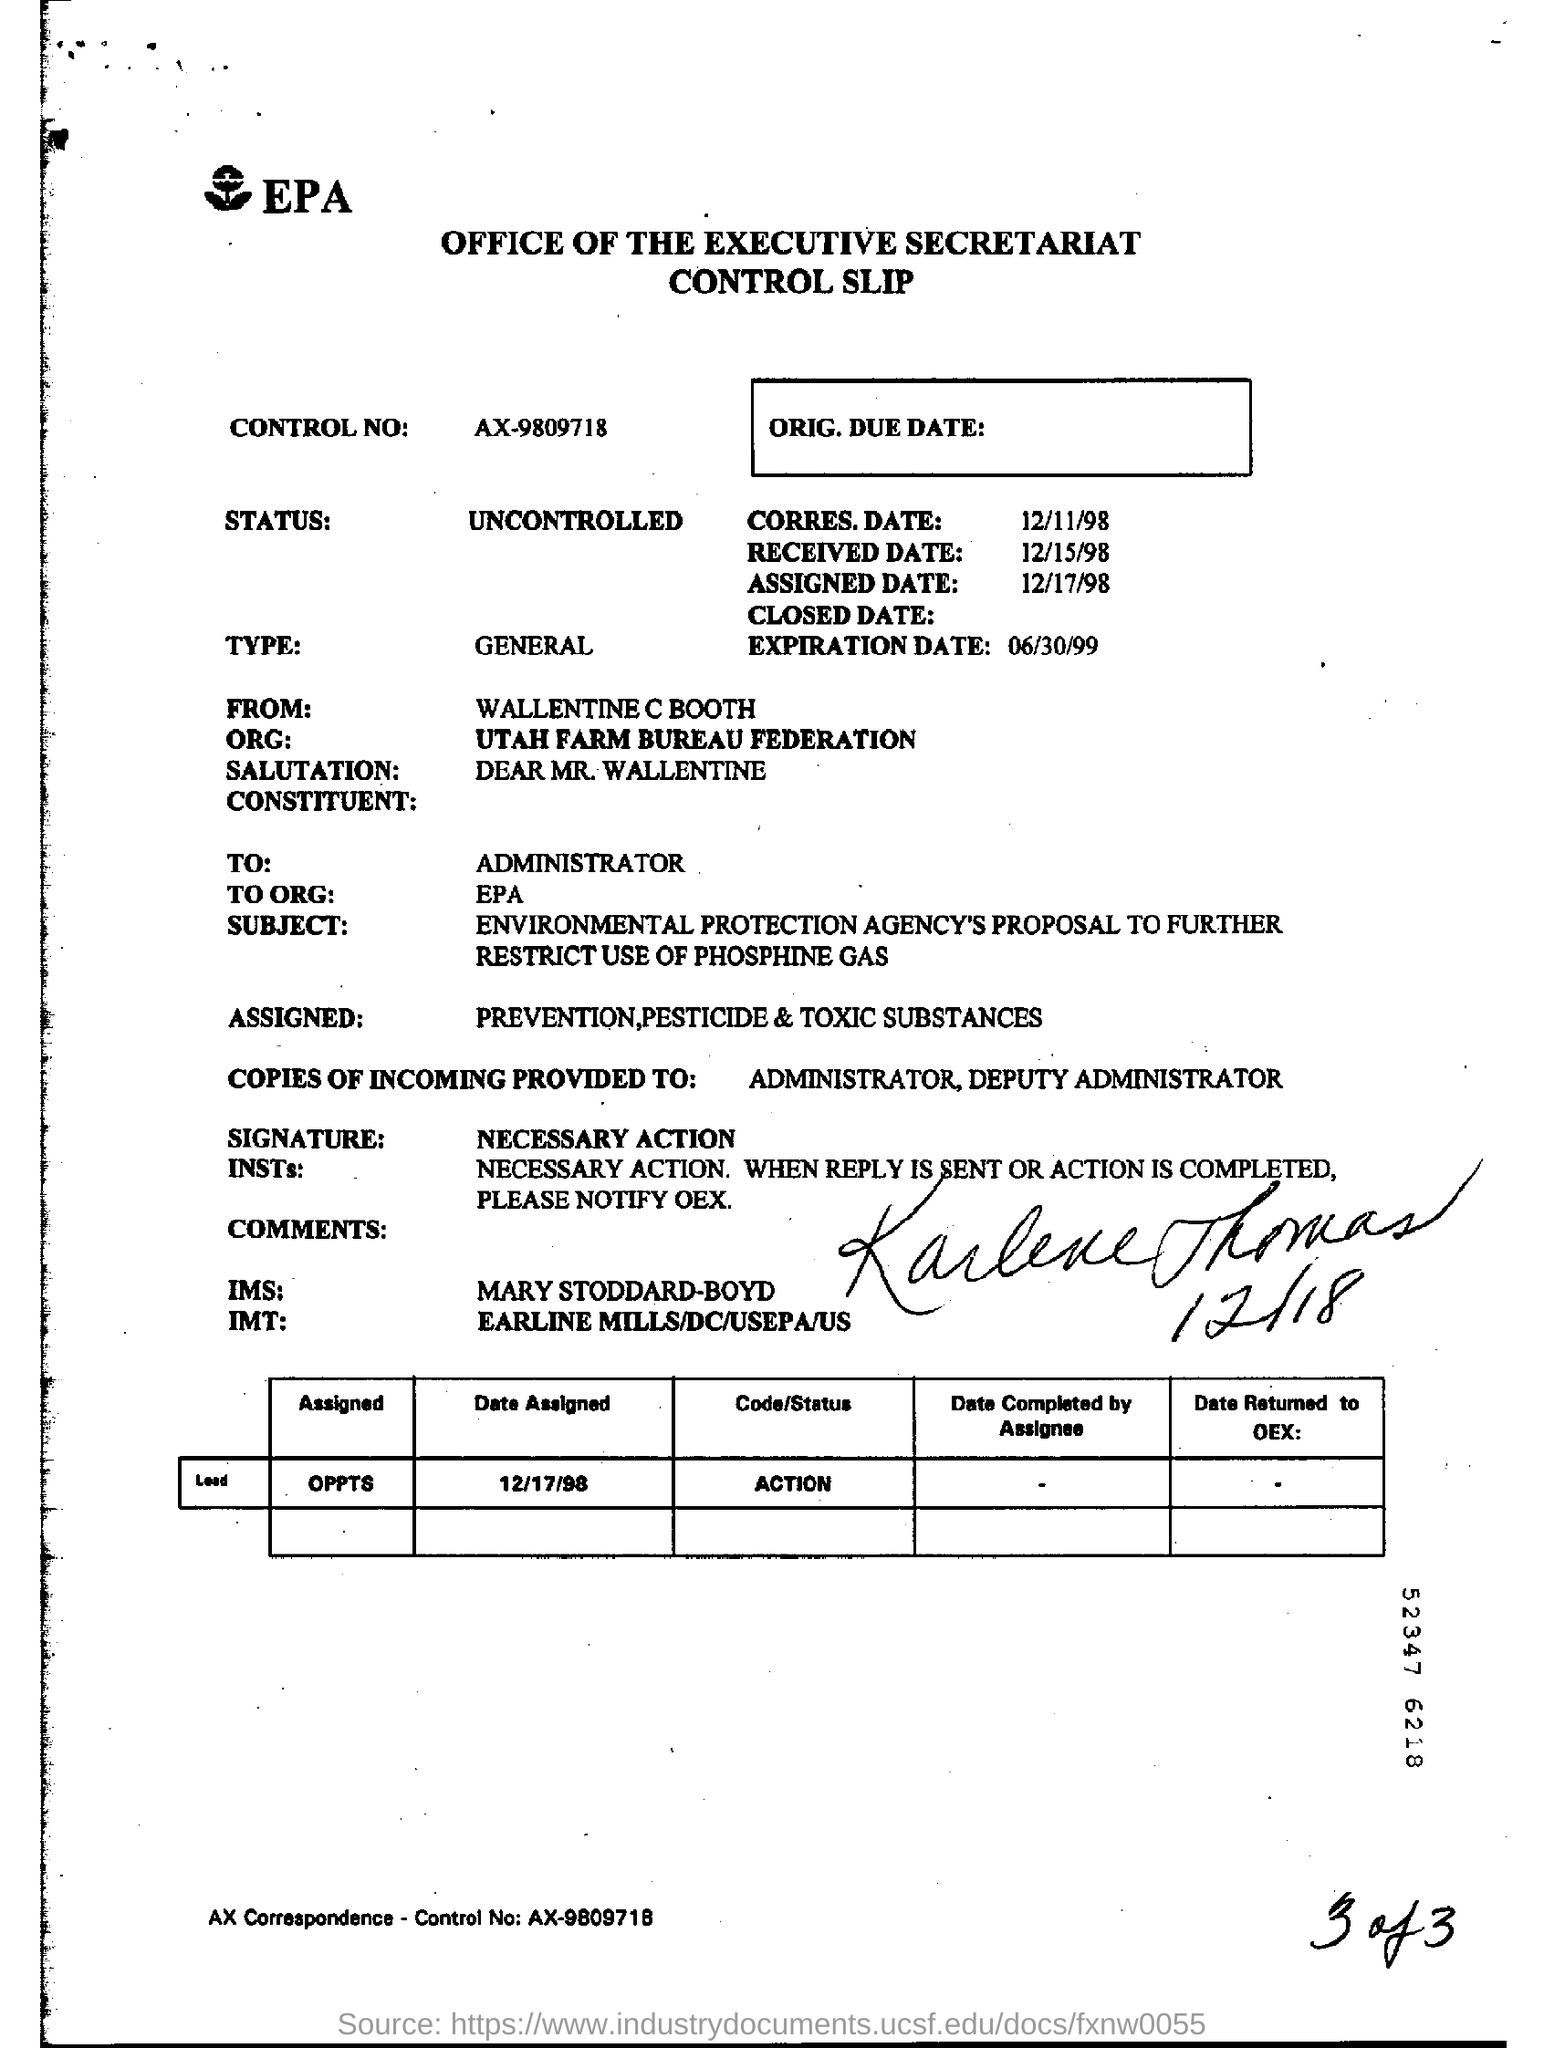What is the control no?
Offer a very short reply. AX-9809718. What is the status?
Your response must be concise. UNCONTROLLED. From whom is the slip?
Provide a short and direct response. WALLENTINE C BOOTH. What is the expiration date?
Ensure brevity in your answer.  06/30/99. 